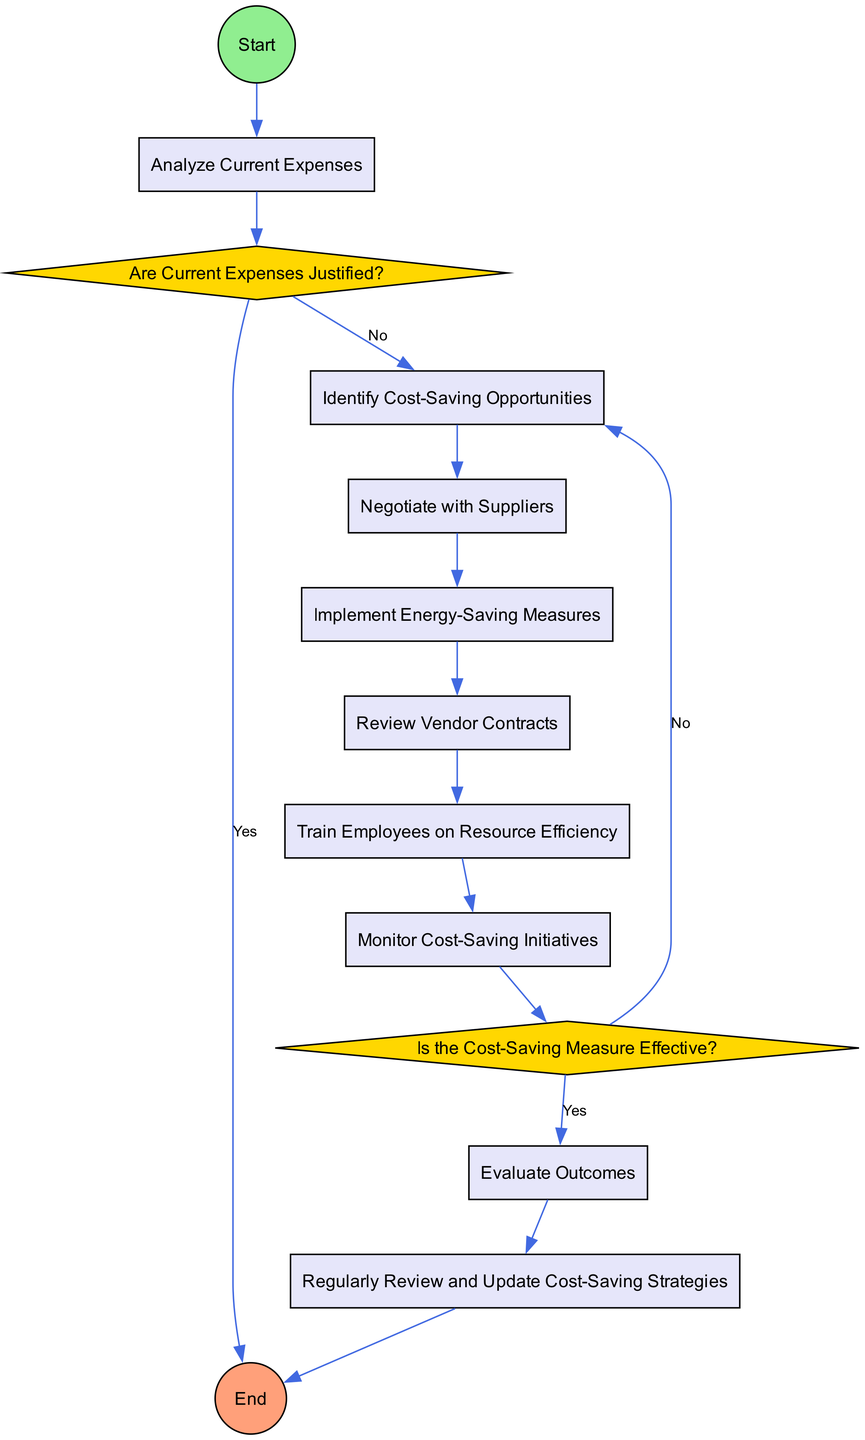What is the first activity in the diagram? The first activity is represented by the node directly connected to the "Start" node, which is "Analyze Current Expenses".
Answer: Analyze Current Expenses How many activities are present in the diagram? By counting the nodes that represent activities, there are a total of 8 activities listed in the diagram.
Answer: 8 What happens if the current expenses are justified? If the current expenses are justified, the flow leads to the "End" node, indicating that there are no further actions required.
Answer: End What is the decision made after monitoring cost-saving initiatives? The decision made is whether the cost-saving measure is effective or not, which determines the next steps in the process.
Answer: Is the Cost-Saving Measure Effective? What activity follows "Implement Energy-Saving Measures"? The activity that follows "Implement Energy-Saving Measures" is "Review Vendor Contracts," as indicated by the flow connecting these two nodes.
Answer: Review Vendor Contracts If the cost-saving measure is not effective, what course of action is taken? If the cost-saving measure is not effective, the action returns to "Identify Cost-Saving Opportunities," indicating the need to seek new solutions again.
Answer: Identify Cost-Saving Opportunities What is the last activity before reaching the End? The last activity before reaching "End" is "Regularly Review and Update Cost-Saving Strategies," which is the final point of the flow in the diagram.
Answer: Regularly Review and Update Cost-Saving Strategies How are cost-saving opportunities initiated? Cost-saving opportunities are initiated after analyzing current expenses and determining that they are not justified based on the decision made in the diagram.
Answer: Identify Cost-Saving Opportunities Which two activities are primarily focused on training? The activities focused on training are "Train Employees on Resource Efficiency" and "Monitor Cost-Saving Initiatives," which emphasizes education and tracking.
Answer: Train Employees on Resource Efficiency and Monitor Cost-Saving Initiatives 